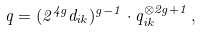Convert formula to latex. <formula><loc_0><loc_0><loc_500><loc_500>q = ( 2 ^ { 4 g } d _ { i k } ) ^ { g - 1 } \cdot q _ { i k } ^ { \otimes 2 g + 1 } \, ,</formula> 